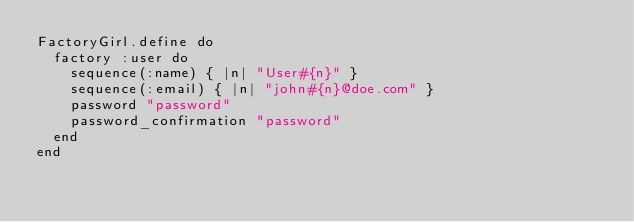Convert code to text. <code><loc_0><loc_0><loc_500><loc_500><_Ruby_>FactoryGirl.define do
  factory :user do
    sequence(:name) { |n| "User#{n}" }
    sequence(:email) { |n| "john#{n}@doe.com" }
    password "password"
    password_confirmation "password"
  end
end
</code> 